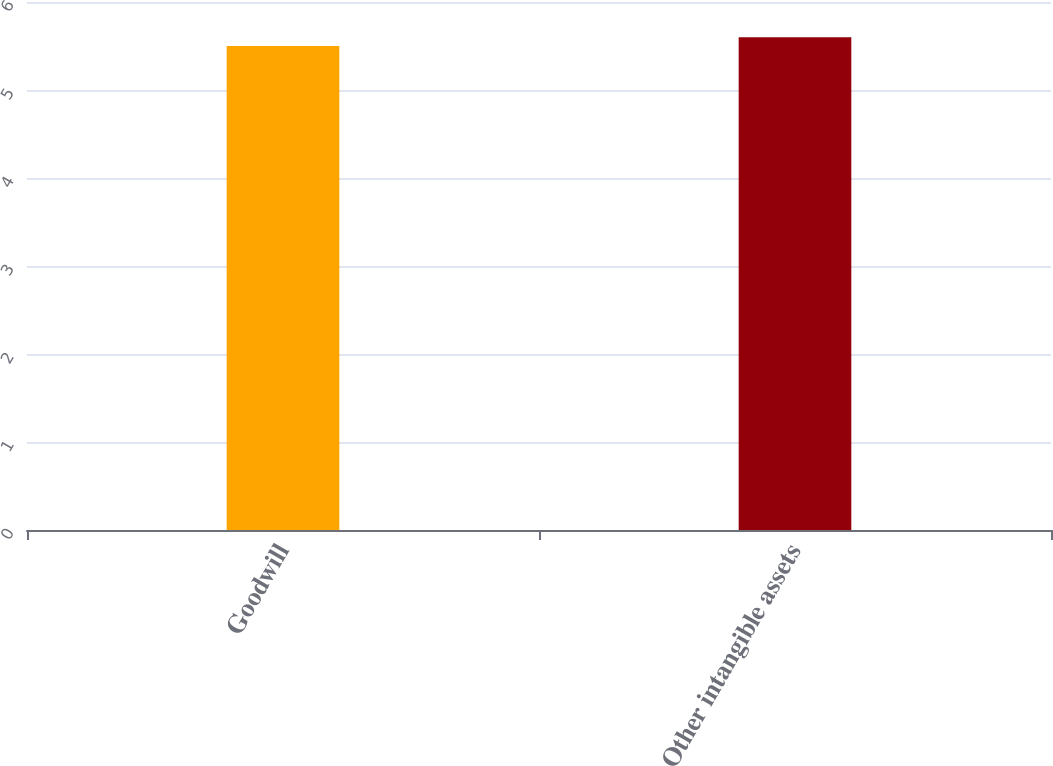Convert chart to OTSL. <chart><loc_0><loc_0><loc_500><loc_500><bar_chart><fcel>Goodwill<fcel>Other intangible assets<nl><fcel>5.5<fcel>5.6<nl></chart> 